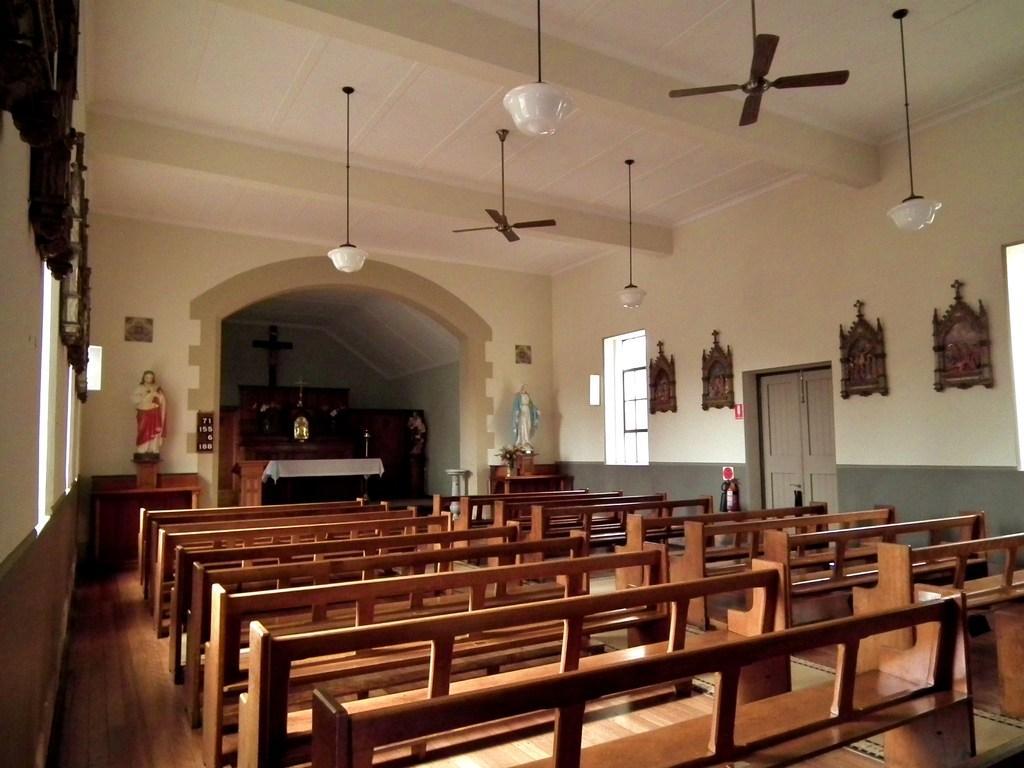Could you give a brief overview of what you see in this image? In this image I can see few benches in brown color, background I can see two statues, few frames attached to the wall and the wall is in white and gray color and I can also see few lights, fans. I can also see few windows, background I can see few tables and cupboards. 